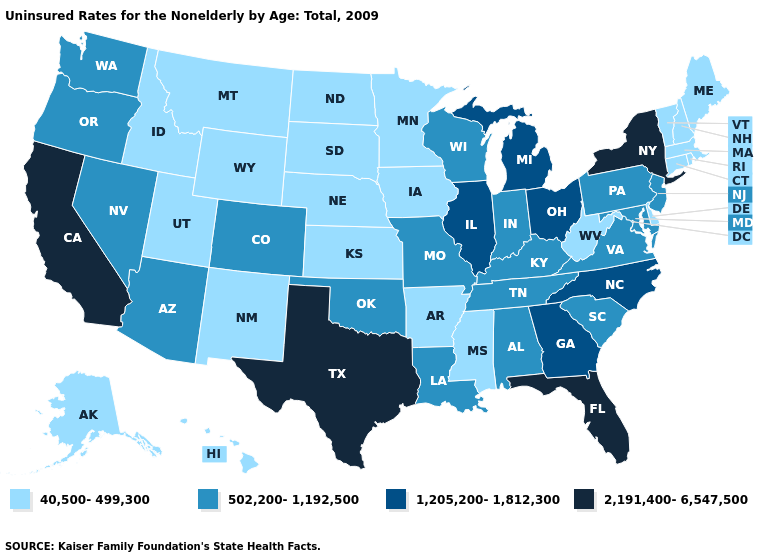Is the legend a continuous bar?
Quick response, please. No. Name the states that have a value in the range 1,205,200-1,812,300?
Answer briefly. Georgia, Illinois, Michigan, North Carolina, Ohio. What is the value of Wyoming?
Write a very short answer. 40,500-499,300. Is the legend a continuous bar?
Write a very short answer. No. What is the value of South Carolina?
Concise answer only. 502,200-1,192,500. What is the value of Nevada?
Short answer required. 502,200-1,192,500. What is the lowest value in the South?
Answer briefly. 40,500-499,300. Among the states that border Missouri , which have the lowest value?
Give a very brief answer. Arkansas, Iowa, Kansas, Nebraska. Name the states that have a value in the range 1,205,200-1,812,300?
Short answer required. Georgia, Illinois, Michigan, North Carolina, Ohio. What is the value of Colorado?
Give a very brief answer. 502,200-1,192,500. What is the value of Nevada?
Be succinct. 502,200-1,192,500. What is the value of Virginia?
Short answer required. 502,200-1,192,500. What is the lowest value in the MidWest?
Give a very brief answer. 40,500-499,300. What is the value of Maine?
Short answer required. 40,500-499,300. What is the value of Rhode Island?
Write a very short answer. 40,500-499,300. 